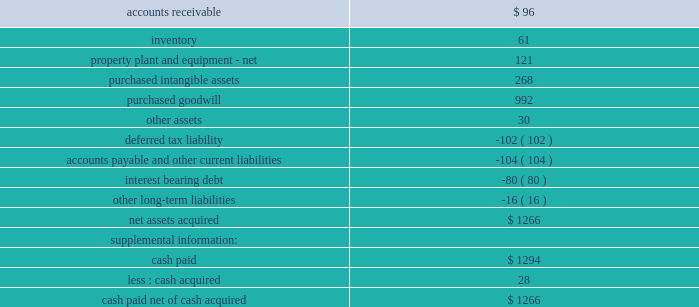Calculations would be adjusted for interest expense associated with this debt instrument .
Eitf issue no .
04-08 would have been effective beginning with the company 2019s 2004 fourth quarter .
However , due to the fasb 2019s delay in issuing sfas no .
128r and the company 2019s intent and ability to settle this debt security in cash versus the issuance of stock , the impact of the additional diluted shares will not be included in the diluted earnings per share calculation until the proposed sfas no .
128r is effective .
When sfas no .
128r is effective , prior periods 2019 diluted shares outstanding and diluted earnings per share amounts will be restated to present comparable information .
The estimated annual reduction in the company 2019s diluted earnings per share would have been approximately $ .02 to $ .03 per share for total year 2005 , 2004 and 2003 .
Because the impact of this standard is ongoing , the company 2019s diluted shares outstanding and diluted earnings per share amounts would be impacted until retirement or modification of certain terms of this debt security .
Note 2 .
Acquisitions and divestitures the company acquired cuno on august 2 , 2005 .
The operating results of cuno are included in the industrial business segment .
Cuno is engaged in the design , manufacture and marketing of a comprehensive line of filtration products for the separation , clarification and purification of fluids and gases .
3m and cuno have complementary sets of filtration technologies and the opportunity to bring an even wider range of filtration solutions to customers around the world .
3m acquired cuno for approximately $ 1.36 billion , comprised of $ 1.27 billion of cash paid ( net of cash acquired ) and the acquisition of $ 80 million of debt , most of which has been repaid .
Purchased identifiable intangible assets of $ 268 million for the cuno acquisition will be amortized on a straight- line basis over lives ranging from 5 to 20 years ( weighted-average life of 15 years ) .
In-process research and development charges from the cuno acquisition were not material .
Pro forma information related to this acquisition is not included because its impact on company 2019s consolidated results of operations is not considered to be material .
The preliminary allocation of the purchase price is presented in the table that follows .
2005 cuno acquisition asset ( liability ) ( millions ) .
During the year ended december 31 , 2005 , 3m entered into two immaterial additional business combinations for a total purchase price of $ 27 million , net of cash acquired .
1 ) 3m ( electro and communications business ) purchased certain assets of siemens ultrasound division 2019s flexible circuit manufacturing line , a u.s .
Operation .
The acquired operation produces flexible interconnect circuits that provide electrical connections between components in electronics systems used primarily in the transducers of ultrasound machines .
2 ) 3m ( display and graphics business ) purchased certain assets of mercury online solutions inc. , a u.s .
Operation .
The acquired operation provides hardware and software technologies and network management services for digital signage and interactive kiosk networks. .
What was the percent of the accounts receivable of the net assets acquired? 
Computations: (96 / 1266)
Answer: 0.07583. 